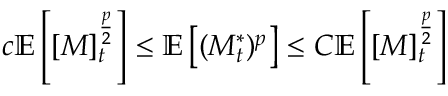Convert formula to latex. <formula><loc_0><loc_0><loc_500><loc_500>c \mathbb { E } \left [ [ M ] _ { t } ^ { \frac { p } { 2 } } \right ] \leq \mathbb { E } \left [ ( M _ { t } ^ { * } ) ^ { p } \right ] \leq C \mathbb { E } \left [ [ M ] _ { t } ^ { \frac { p } { 2 } } \right ]</formula> 